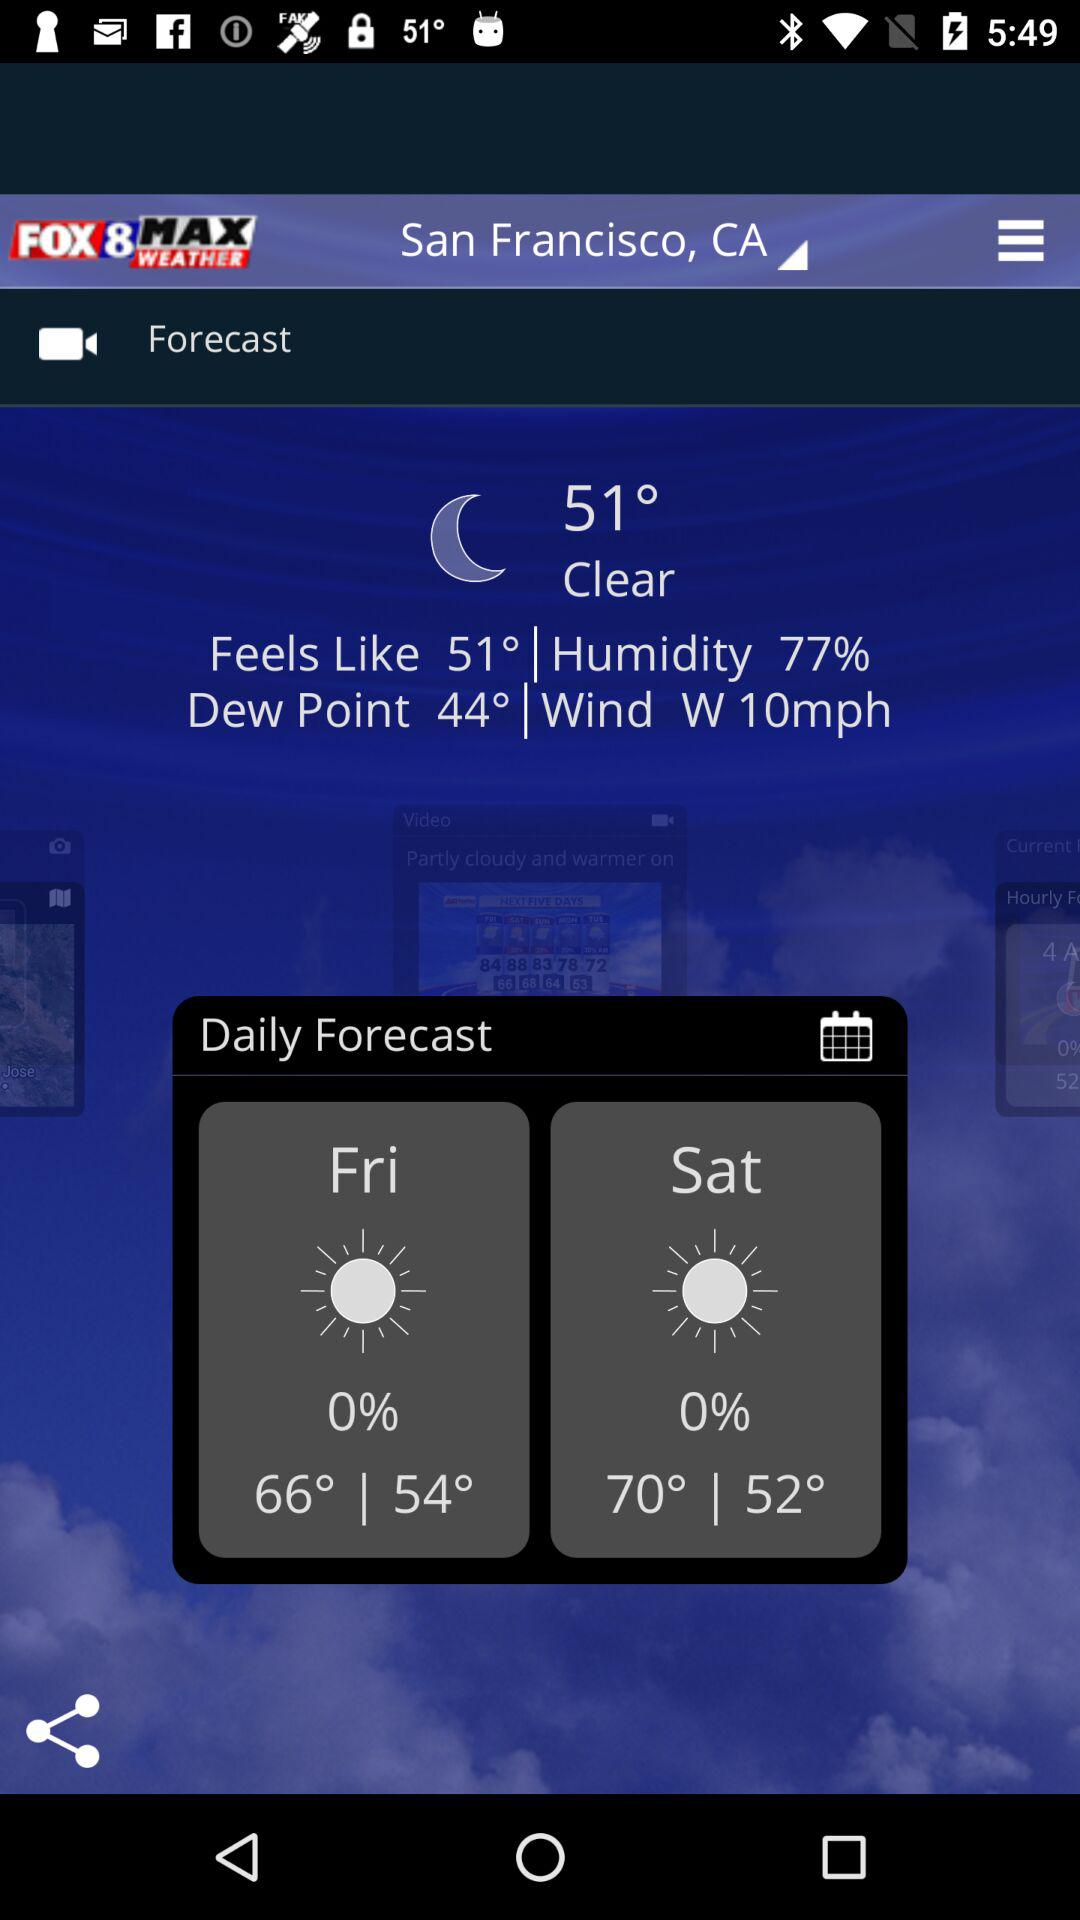What is the wind speed? The wind speed is 10 mph. 